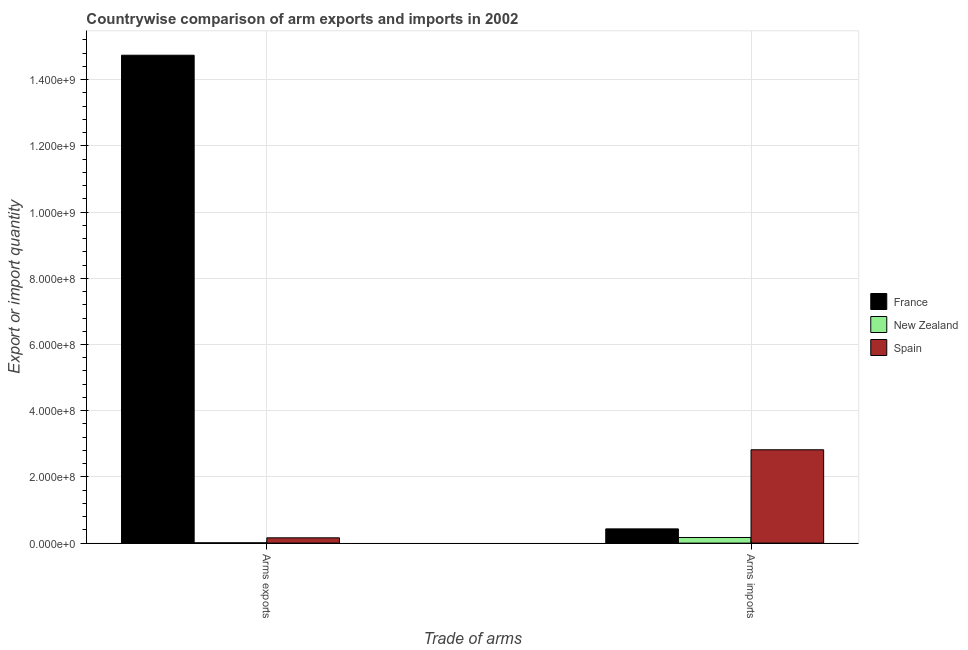How many different coloured bars are there?
Offer a very short reply. 3. How many groups of bars are there?
Make the answer very short. 2. Are the number of bars on each tick of the X-axis equal?
Ensure brevity in your answer.  Yes. How many bars are there on the 1st tick from the left?
Offer a terse response. 3. What is the label of the 1st group of bars from the left?
Offer a terse response. Arms exports. What is the arms exports in New Zealand?
Your answer should be very brief. 1.00e+06. Across all countries, what is the maximum arms imports?
Give a very brief answer. 2.82e+08. Across all countries, what is the minimum arms imports?
Offer a terse response. 1.70e+07. In which country was the arms exports minimum?
Your answer should be compact. New Zealand. What is the total arms imports in the graph?
Make the answer very short. 3.42e+08. What is the difference between the arms imports in New Zealand and that in Spain?
Make the answer very short. -2.65e+08. What is the difference between the arms exports in Spain and the arms imports in France?
Make the answer very short. -2.70e+07. What is the average arms imports per country?
Your response must be concise. 1.14e+08. What is the difference between the arms exports and arms imports in France?
Keep it short and to the point. 1.43e+09. In how many countries, is the arms imports greater than the average arms imports taken over all countries?
Ensure brevity in your answer.  1. What does the 1st bar from the left in Arms exports represents?
Your answer should be very brief. France. How many bars are there?
Provide a succinct answer. 6. Are all the bars in the graph horizontal?
Make the answer very short. No. How many countries are there in the graph?
Provide a succinct answer. 3. What is the difference between two consecutive major ticks on the Y-axis?
Give a very brief answer. 2.00e+08. Does the graph contain any zero values?
Your answer should be very brief. No. Does the graph contain grids?
Your response must be concise. Yes. What is the title of the graph?
Provide a short and direct response. Countrywise comparison of arm exports and imports in 2002. What is the label or title of the X-axis?
Make the answer very short. Trade of arms. What is the label or title of the Y-axis?
Offer a very short reply. Export or import quantity. What is the Export or import quantity of France in Arms exports?
Offer a very short reply. 1.47e+09. What is the Export or import quantity in New Zealand in Arms exports?
Give a very brief answer. 1.00e+06. What is the Export or import quantity in Spain in Arms exports?
Offer a very short reply. 1.60e+07. What is the Export or import quantity in France in Arms imports?
Offer a very short reply. 4.30e+07. What is the Export or import quantity of New Zealand in Arms imports?
Provide a succinct answer. 1.70e+07. What is the Export or import quantity in Spain in Arms imports?
Provide a succinct answer. 2.82e+08. Across all Trade of arms, what is the maximum Export or import quantity of France?
Give a very brief answer. 1.47e+09. Across all Trade of arms, what is the maximum Export or import quantity of New Zealand?
Offer a very short reply. 1.70e+07. Across all Trade of arms, what is the maximum Export or import quantity of Spain?
Provide a short and direct response. 2.82e+08. Across all Trade of arms, what is the minimum Export or import quantity of France?
Offer a terse response. 4.30e+07. Across all Trade of arms, what is the minimum Export or import quantity of Spain?
Your answer should be very brief. 1.60e+07. What is the total Export or import quantity in France in the graph?
Offer a terse response. 1.52e+09. What is the total Export or import quantity of New Zealand in the graph?
Your answer should be very brief. 1.80e+07. What is the total Export or import quantity of Spain in the graph?
Keep it short and to the point. 2.98e+08. What is the difference between the Export or import quantity of France in Arms exports and that in Arms imports?
Offer a very short reply. 1.43e+09. What is the difference between the Export or import quantity in New Zealand in Arms exports and that in Arms imports?
Provide a succinct answer. -1.60e+07. What is the difference between the Export or import quantity in Spain in Arms exports and that in Arms imports?
Ensure brevity in your answer.  -2.66e+08. What is the difference between the Export or import quantity of France in Arms exports and the Export or import quantity of New Zealand in Arms imports?
Make the answer very short. 1.46e+09. What is the difference between the Export or import quantity of France in Arms exports and the Export or import quantity of Spain in Arms imports?
Offer a terse response. 1.19e+09. What is the difference between the Export or import quantity in New Zealand in Arms exports and the Export or import quantity in Spain in Arms imports?
Provide a succinct answer. -2.81e+08. What is the average Export or import quantity in France per Trade of arms?
Provide a short and direct response. 7.58e+08. What is the average Export or import quantity of New Zealand per Trade of arms?
Keep it short and to the point. 9.00e+06. What is the average Export or import quantity in Spain per Trade of arms?
Offer a terse response. 1.49e+08. What is the difference between the Export or import quantity in France and Export or import quantity in New Zealand in Arms exports?
Your answer should be very brief. 1.47e+09. What is the difference between the Export or import quantity in France and Export or import quantity in Spain in Arms exports?
Ensure brevity in your answer.  1.46e+09. What is the difference between the Export or import quantity of New Zealand and Export or import quantity of Spain in Arms exports?
Offer a very short reply. -1.50e+07. What is the difference between the Export or import quantity in France and Export or import quantity in New Zealand in Arms imports?
Keep it short and to the point. 2.60e+07. What is the difference between the Export or import quantity in France and Export or import quantity in Spain in Arms imports?
Make the answer very short. -2.39e+08. What is the difference between the Export or import quantity of New Zealand and Export or import quantity of Spain in Arms imports?
Offer a very short reply. -2.65e+08. What is the ratio of the Export or import quantity of France in Arms exports to that in Arms imports?
Keep it short and to the point. 34.28. What is the ratio of the Export or import quantity in New Zealand in Arms exports to that in Arms imports?
Make the answer very short. 0.06. What is the ratio of the Export or import quantity of Spain in Arms exports to that in Arms imports?
Keep it short and to the point. 0.06. What is the difference between the highest and the second highest Export or import quantity in France?
Provide a short and direct response. 1.43e+09. What is the difference between the highest and the second highest Export or import quantity of New Zealand?
Provide a short and direct response. 1.60e+07. What is the difference between the highest and the second highest Export or import quantity of Spain?
Provide a succinct answer. 2.66e+08. What is the difference between the highest and the lowest Export or import quantity of France?
Ensure brevity in your answer.  1.43e+09. What is the difference between the highest and the lowest Export or import quantity of New Zealand?
Offer a terse response. 1.60e+07. What is the difference between the highest and the lowest Export or import quantity in Spain?
Your response must be concise. 2.66e+08. 